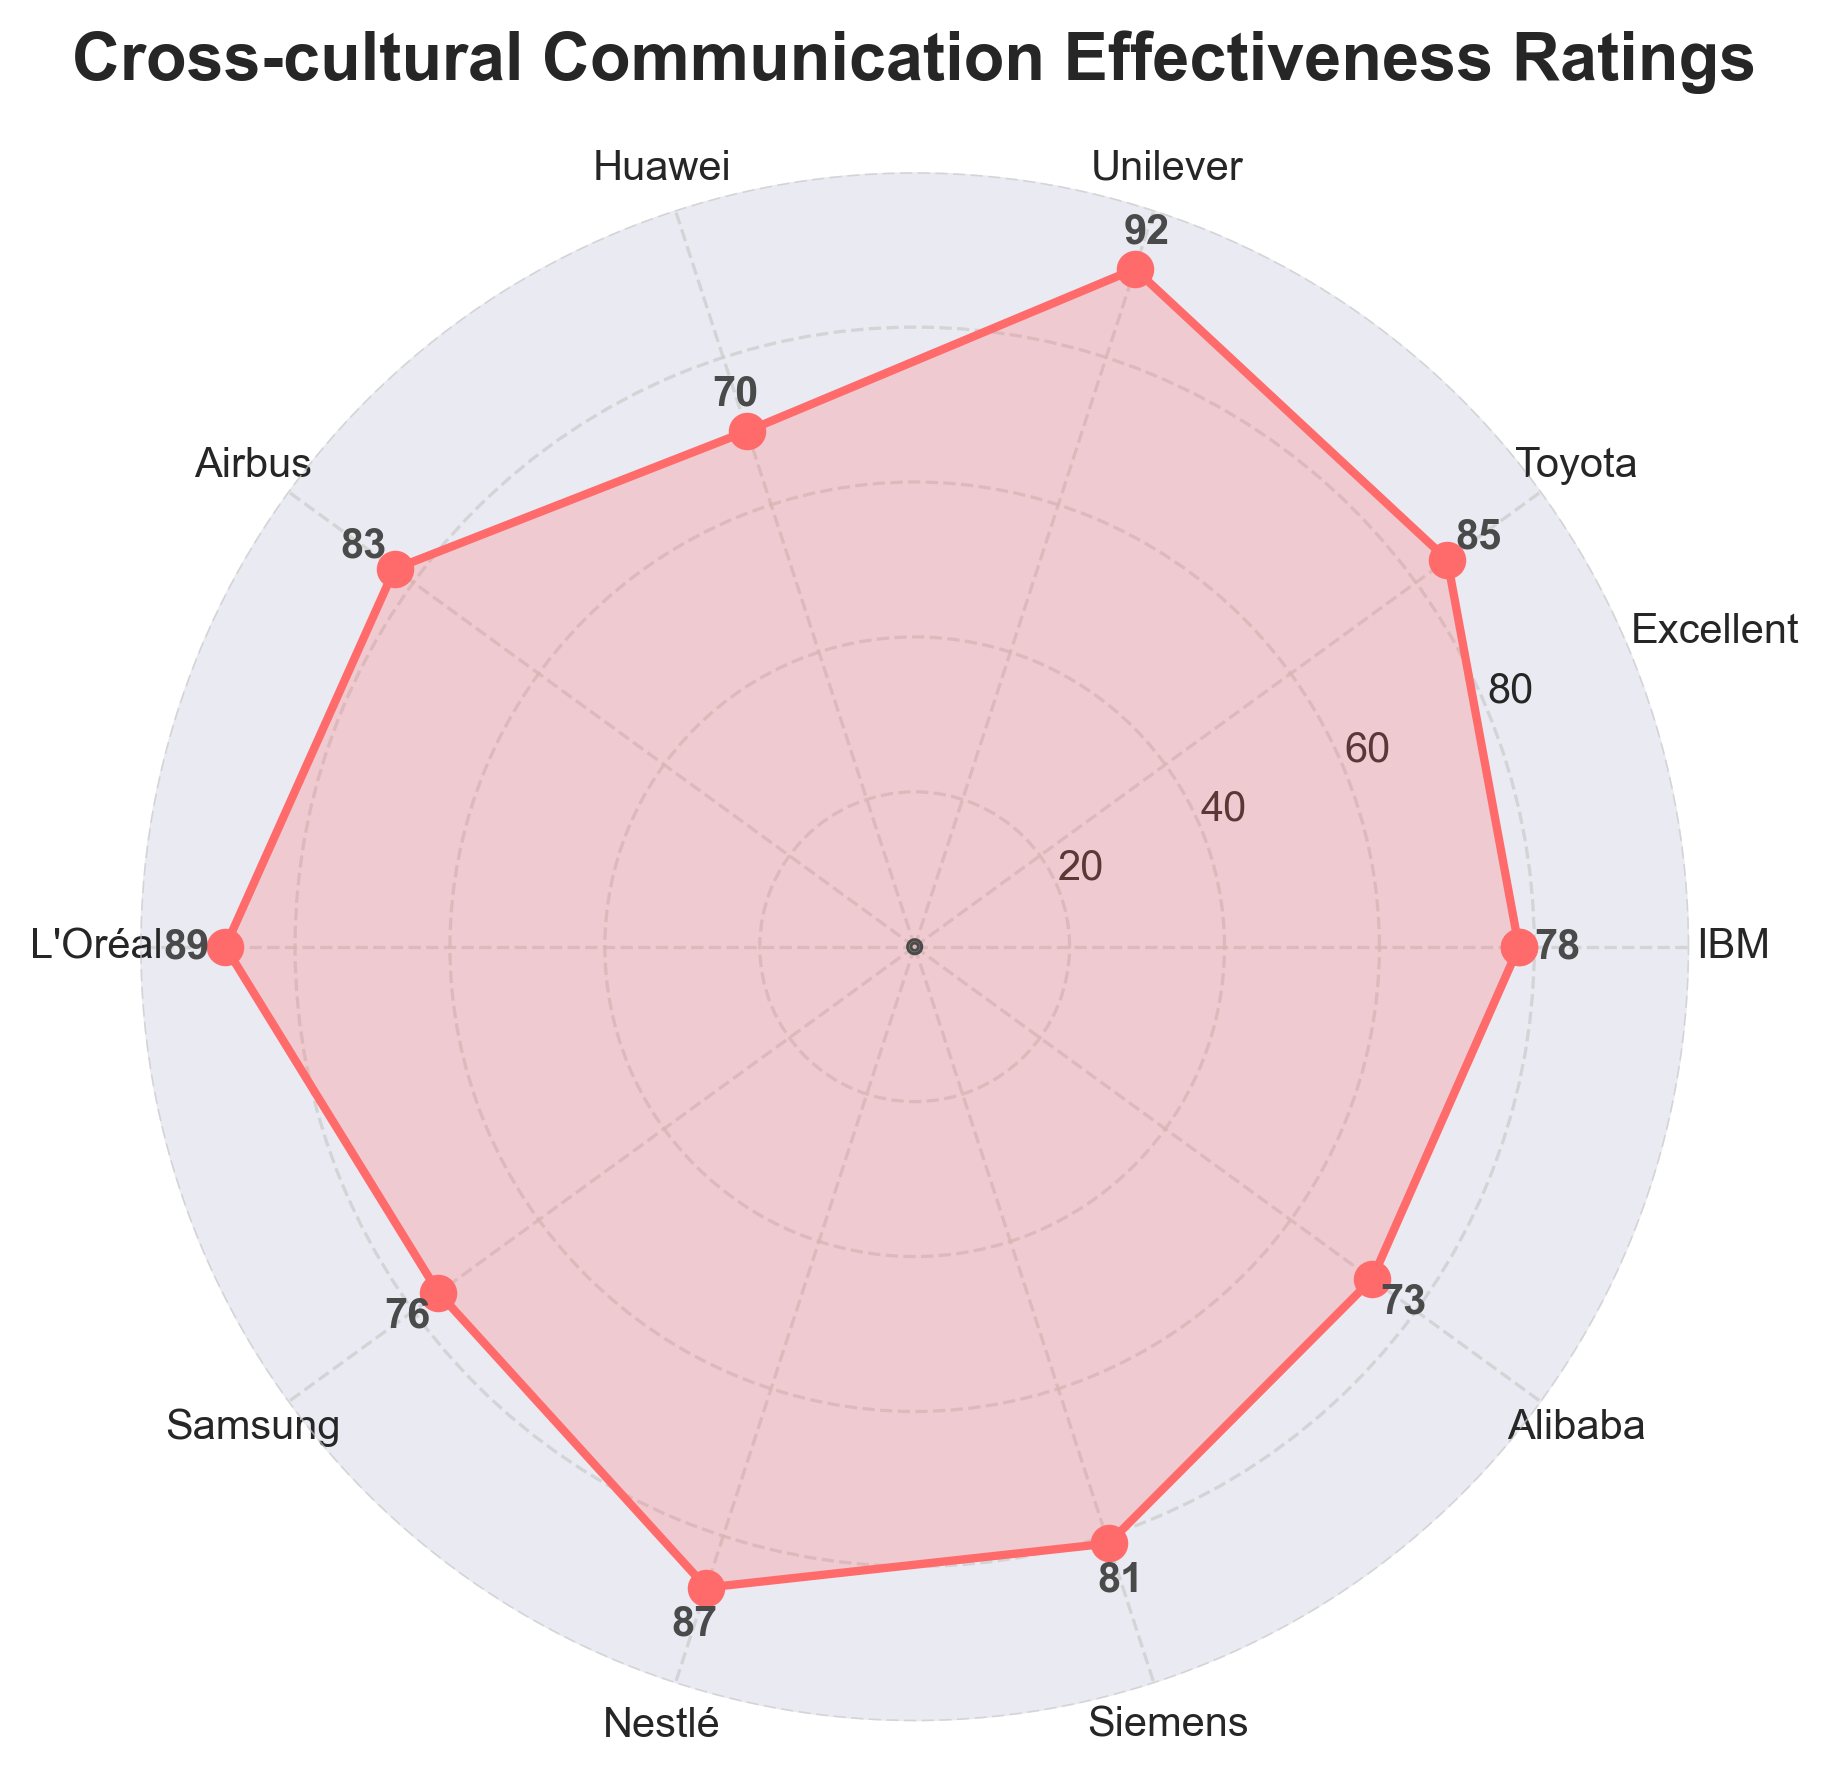What is the title of the figure? The title is visually prominent at the top of the figure, above the polar plot.
Answer: Cross-cultural Communication Effectiveness Ratings How many companies' ratings are plotted in the figure? Count the number of unique company labels along the outer edge of the polar chart.
Answer: 10 Which company has the highest rating for cross-cultural communication effectiveness? Compare the ratings of all companies; the company with the highest value is noted at the figure.
Answer: Unilever What is the rating of Huawei? Locate the label for Huawei on the chart, then refer to the corresponding rating number near the label.
Answer: 70 What is the difference in ratings between L'Oréal and Huawei? Find the ratings for both L'Oréal (89) and Huawei (70) and subtract the smaller number from the larger one (89 - 70).
Answer: 19 Which company has a lower rating, Alibaba or Samsung, and by how much? Compare the ratings of Alibaba (73) and Samsung (76), then subtract the smaller rating from the larger (76 - 73).
Answer: Alibaba by 3 What is the average rating of all the companies? Sum all the ratings and divide by the number of companies (78 + 85 + 92 + 70 + 83 + 89 + 76 + 87 + 81 + 73) / 10 = 814/10.
Answer: 81.4 How is the excellent rating displayed visually on the chart? Identify textual labels for ratings; 'Excellent' is described at the outermost tick mark for ratings (100).
Answer: At the outermost circle on the radial axis Which companies have a rating above 85? List all companies with ratings exceeding 85 by comparing each rating one-by-one.
Answer: Toyota, Unilever, L'Oréal, Nestlé What is the color coding used to differentiate sections on the inner circle? Inspect the color pattern of the wedges in the center of the plot; with different colors likely representing different rating ranges.
Answer: A range of colors from red to blue 